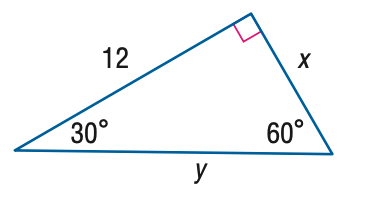Answer the mathemtical geometry problem and directly provide the correct option letter.
Question: Find y.
Choices: A: 8 \sqrt { 3 } B: 12 \sqrt { 3 } C: 24 D: 16 \sqrt { 3 } A 